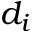<formula> <loc_0><loc_0><loc_500><loc_500>d _ { i }</formula> 